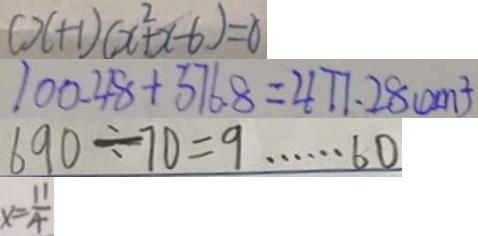Convert formula to latex. <formula><loc_0><loc_0><loc_500><loc_500>( x + 1 ) ( x ^ { 2 } + x - 6 ) = 0 
 1 0 0 . 4 8 + 3 7 6 . 8 = 4 7 7 . 2 8 ( c m ^ { 2 } ) 
 6 9 0 \div 7 0 = 9 \cdots 6 0 
 x = \frac { 1 1 } { 4 }</formula> 